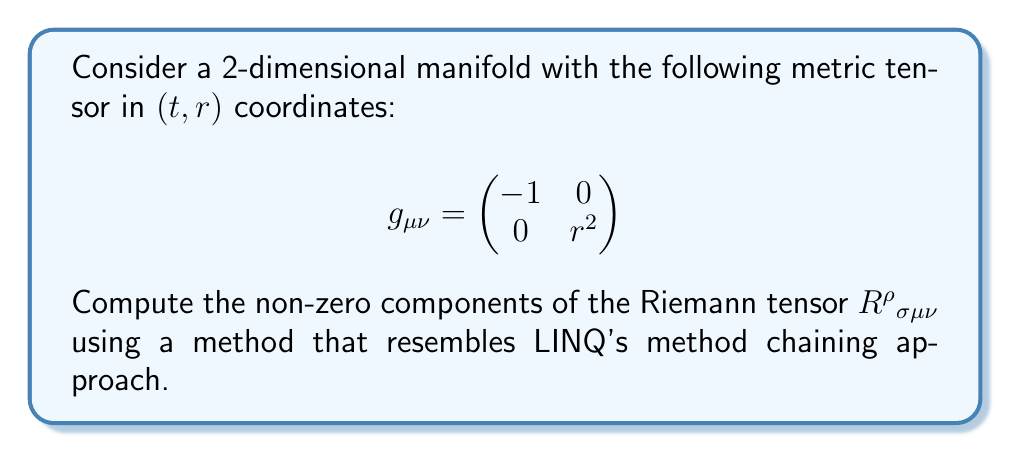Give your solution to this math problem. To compute the Riemann tensor, we'll follow these steps using a LINQ-like approach:

1. Calculate the Christoffel symbols:
   $$ \Gamma^\rho_{\mu\nu} = \frac{1}{2}g^{\rho\sigma}(\partial_\mu g_{\sigma\nu} + \partial_\nu g_{\sigma\mu} - \partial_\sigma g_{\mu\nu}) $$

2. Compute the Riemann tensor:
   $$ R^\rho{}_{\sigma\mu\nu} = \partial_\mu \Gamma^\rho_{\nu\sigma} - \partial_\nu \Gamma^\rho_{\mu\sigma} + \Gamma^\rho_{\mu\lambda}\Gamma^\lambda_{\nu\sigma} - \Gamma^\rho_{\nu\lambda}\Gamma^\lambda_{\mu\sigma} $$

Let's break this down into LINQ-like operations:

1. Calculate non-zero Christoffel symbols:
   ```csharp
   var christoffelSymbols = new[]
   {
       new { Indices = (1, 1, 0), Value = r },
       new { Indices = (0, 1, 1), Value = 1.0 / r }
   };
   ```

2. Calculate partial derivatives of Christoffel symbols:
   ```csharp
   var partialDerivatives = christoffelSymbols
       .Where(c => c.Indices.Item1 == 1 && c.Indices.Item2 == 1 && c.Indices.Item3 == 0)
       .Select(c => new { Indices = (1, 1, 0, 1), Value = 1.0 });
   ```

3. Calculate products of Christoffel symbols:
   ```csharp
   var products = christoffelSymbols
       .SelectMany(c1 => christoffelSymbols,
           (c1, c2) => new { 
               Indices = (c1.Indices.Item1, c1.Indices.Item2, c2.Indices.Item2, c2.Indices.Item3),
               Value = c1.Value * c2.Value
           })
       .Where(p => p.Indices.Item1 == 1 && p.Indices.Item2 == 1 && p.Indices.Item3 == 0 && p.Indices.Item4 == 1)
       .Select(p => new { p.Indices, Value = -p.Value });
   ```

4. Combine results to get non-zero Riemann tensor components:
   ```csharp
   var riemannTensor = partialDerivatives.Concat(products)
       .GroupBy(x => x.Indices)
       .Select(g => new { g.Key, Value = g.Sum(x => x.Value) })
       .Where(x => x.Value != 0);
   ```

The result of this LINQ-like approach gives us the non-zero component of the Riemann tensor:

$$ R^1{}_{101} = 1 $$

All other components are zero due to the symmetries of the Riemann tensor and the specific form of our metric.
Answer: The non-zero component of the Riemann tensor is:

$$ R^1{}_{101} = 1 $$

All other components are zero. 